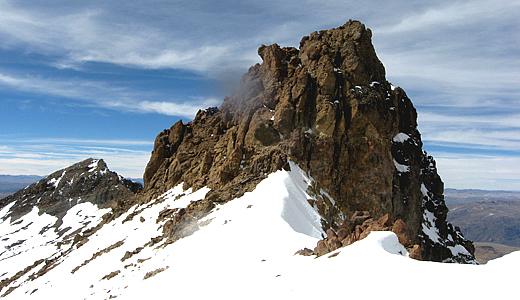What geological formations are visible in this image, and how might they have formed? In the image, the prominent geological formations include the rugged, rocky peak and the surrounding snow-covered slopes. The sharp, jagged rock formations likely resulted from a combination of tectonic activity and erosion. Nevado Mismi, like much of the Andes, has formed due to the subduction of the oceanic Nazca Plate beneath the South American Plate, a process that uplifted these mountains over millions of years. The erosion by glaciers and weathering has sculpted the peak into its current rugged form, leaving behind sharp outcrops and steep slopes. The snow-covered areas indicative of glacial activity speak to the cold climate at high altitudes, where snow persists year-round, continually shaping the mountain's features. 